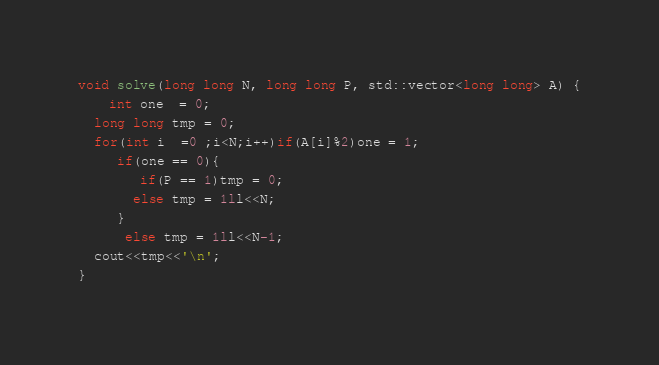Convert code to text. <code><loc_0><loc_0><loc_500><loc_500><_C++_>void solve(long long N, long long P, std::vector<long long> A) {
	int one  = 0;
  long long tmp = 0;
  for(int i  =0 ;i<N;i++)if(A[i]%2)one = 1;
     if(one == 0){
		if(P == 1)tmp = 0;
       else tmp = 1ll<<N;
     }
      else tmp = 1ll<<N-1;
  cout<<tmp<<'\n';
}</code> 